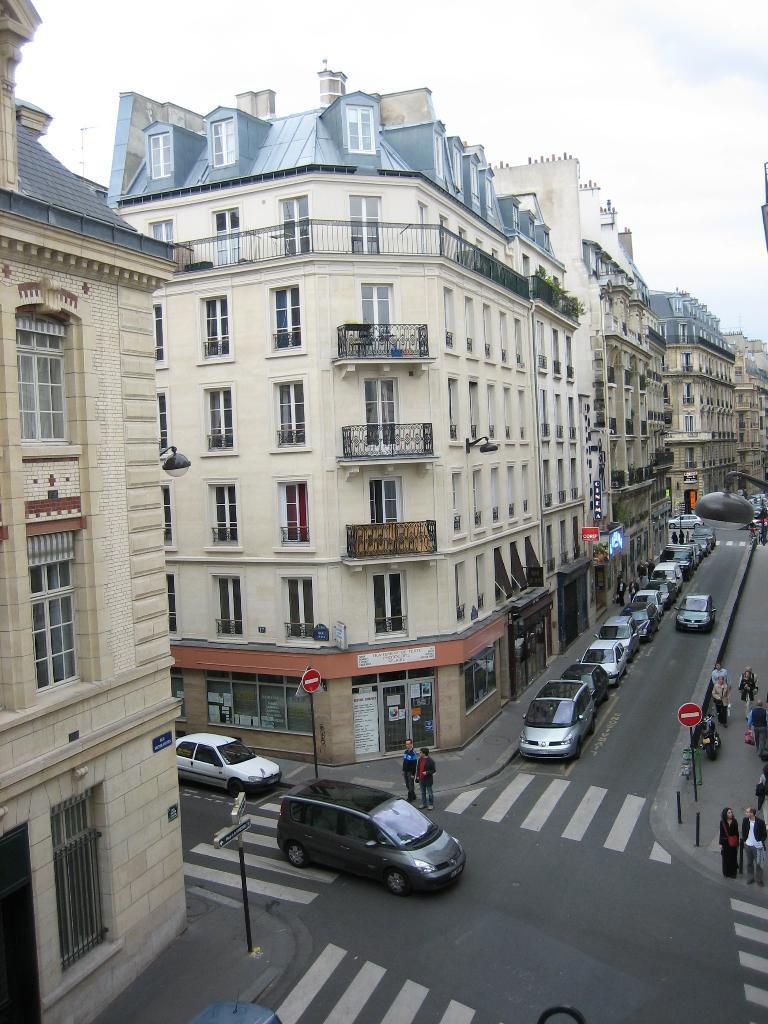Can you describe this image briefly? This picture is clicked outside. In the foreground we can see the zebra crossings and we can see the group of cars and group of persons, we can see the poles, boards the Lamps and some other objects and we can see the buildings, windows and railings of the buildings. In the background we can see the sky and some other objects. 